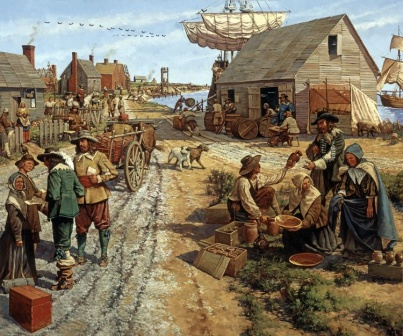Based on the image, describe a long scenario that highlights the daily activities in the marketplace. The marketplace is a bustling hub of activity from dawn till dusk. As the first light breaks, vendors set up their stalls, displaying a vibrant array of fresh produce, handcrafted goods, and exotic items from distant lands. The air is filled with the lively chatter of villagers bargaining and exchanging news. Children weave through the crowd, playing games and delivering messages. A vendor, standing under a colorful awning, enthusiastically promotes his wares, while a group of women nearby exchange recipes and gossip over baskets of freshly picked berries. Farmers arrive with carts laden with vegetables, fruits, and dairy products, their presence indicating the village's agricultural richness. As noon approaches, the marketplace becomes more crowded; villagers come to purchase necessary supplies, while artisans and craftsmen showcase their latest creations. The sound of laughter and the clinking of coins fill the air as the marketplace thrives as the central artery of village life, fostering community ties and fueling the local economy. By evening, as the Sun sets, the marketplace gradually quiets down, with vendors packing up their stalls and heading home, but the essence of the day's interactions lingers in the air, awaiting the next day's bustle. 